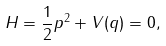Convert formula to latex. <formula><loc_0><loc_0><loc_500><loc_500>H = \frac { 1 } { 2 } p ^ { 2 } + V ( q ) = 0 ,</formula> 